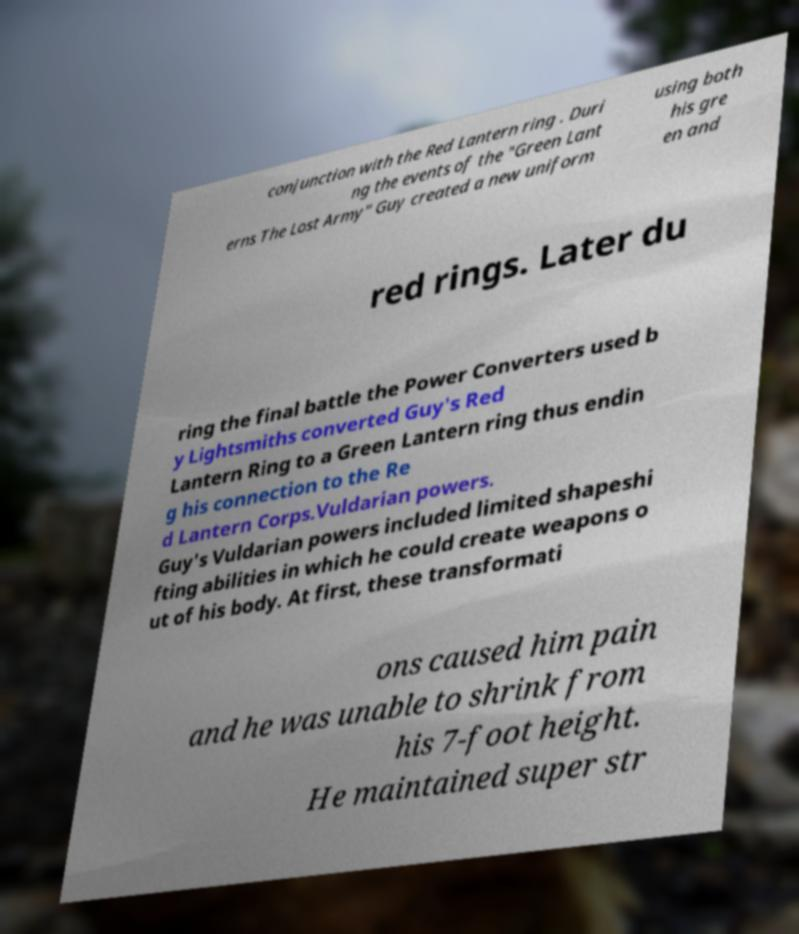Could you extract and type out the text from this image? conjunction with the Red Lantern ring . Duri ng the events of the "Green Lant erns The Lost Army" Guy created a new uniform using both his gre en and red rings. Later du ring the final battle the Power Converters used b y Lightsmiths converted Guy's Red Lantern Ring to a Green Lantern ring thus endin g his connection to the Re d Lantern Corps.Vuldarian powers. Guy's Vuldarian powers included limited shapeshi fting abilities in which he could create weapons o ut of his body. At first, these transformati ons caused him pain and he was unable to shrink from his 7-foot height. He maintained super str 